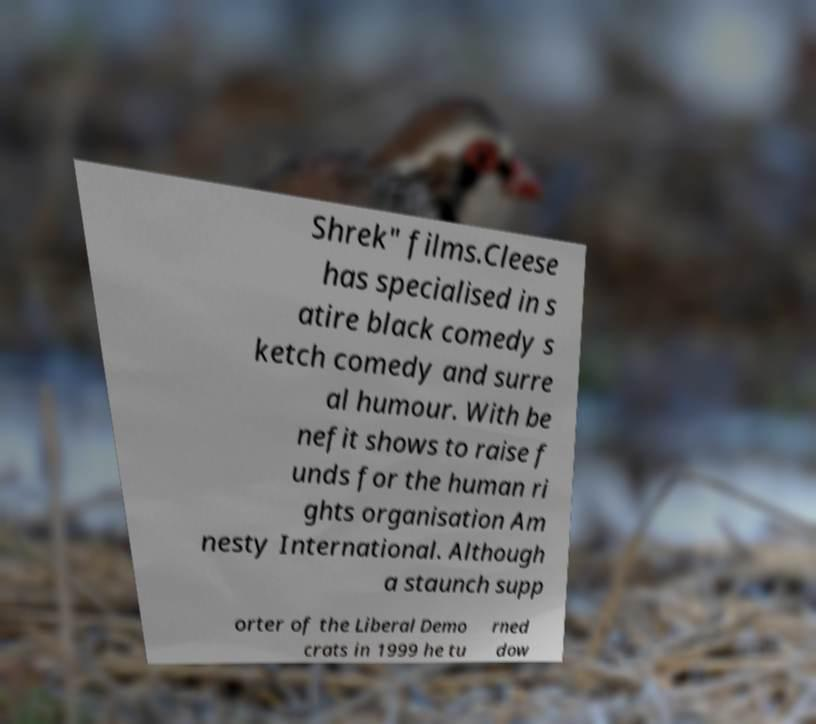I need the written content from this picture converted into text. Can you do that? Shrek" films.Cleese has specialised in s atire black comedy s ketch comedy and surre al humour. With be nefit shows to raise f unds for the human ri ghts organisation Am nesty International. Although a staunch supp orter of the Liberal Demo crats in 1999 he tu rned dow 